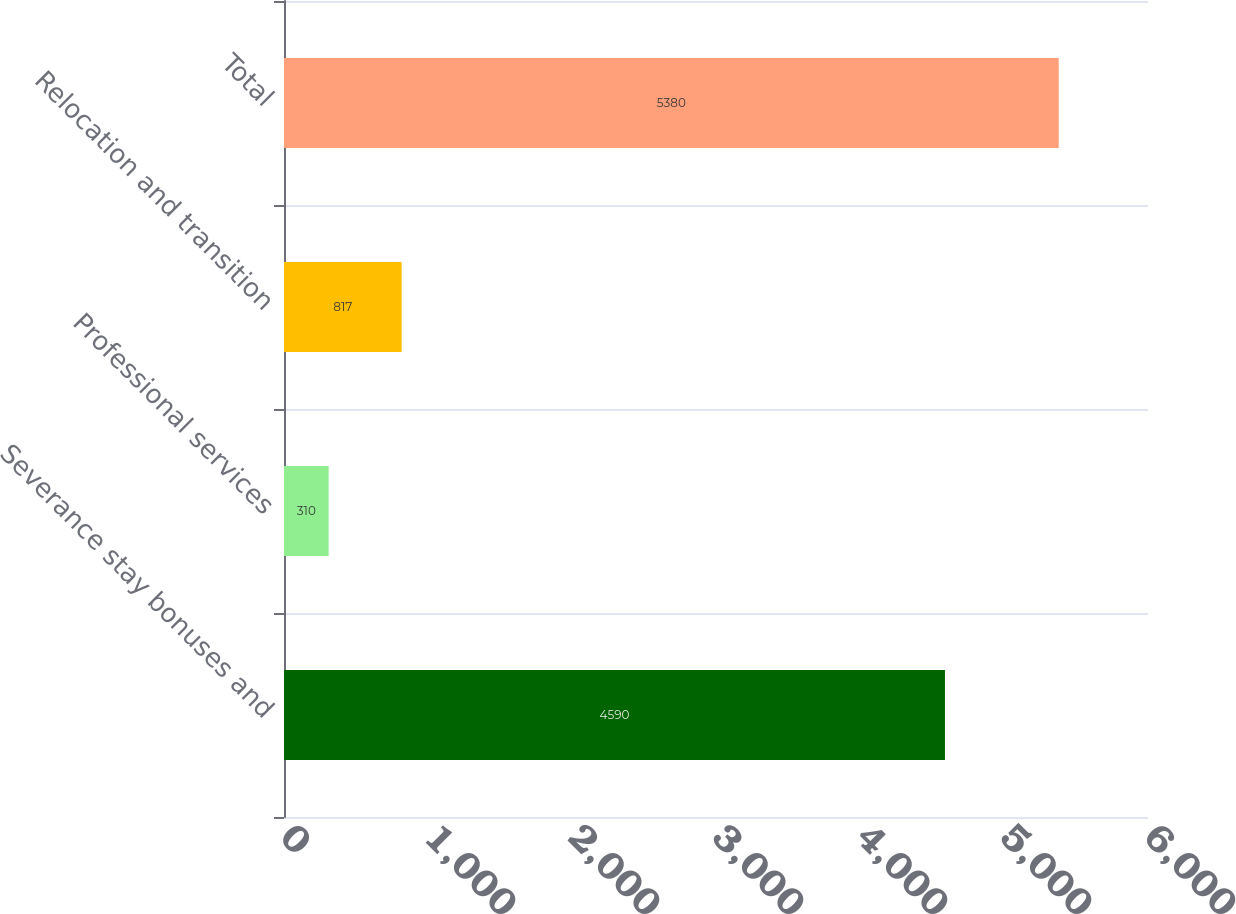Convert chart to OTSL. <chart><loc_0><loc_0><loc_500><loc_500><bar_chart><fcel>Severance stay bonuses and<fcel>Professional services<fcel>Relocation and transition<fcel>Total<nl><fcel>4590<fcel>310<fcel>817<fcel>5380<nl></chart> 